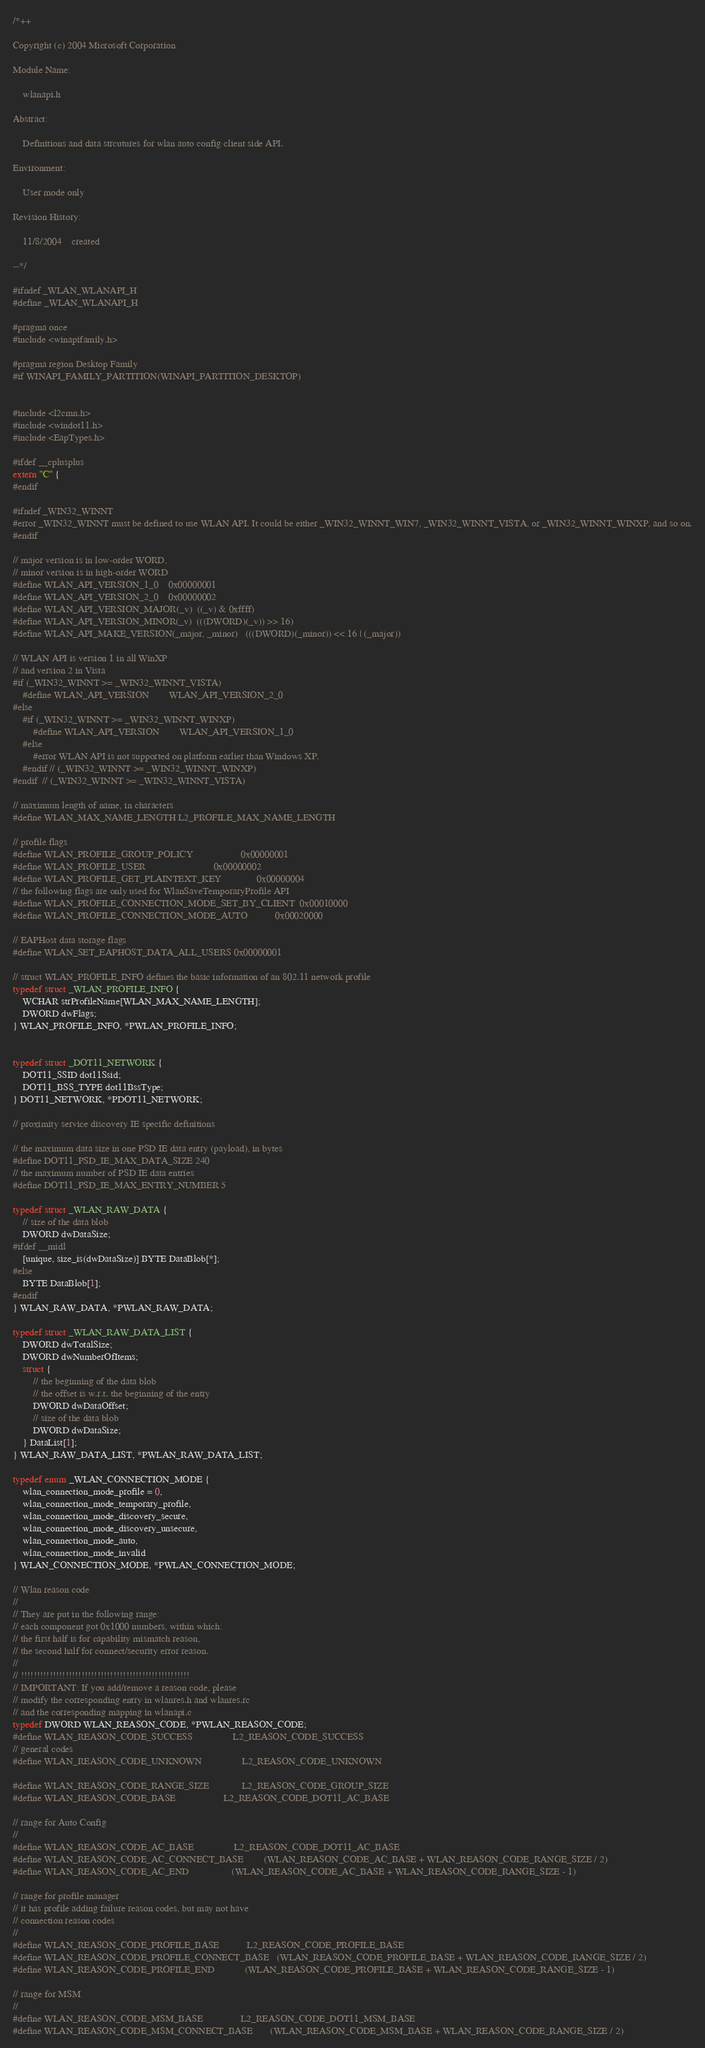<code> <loc_0><loc_0><loc_500><loc_500><_C_>/*++

Copyright (c) 2004 Microsoft Corporation

Module Name:

    wlanapi.h

Abstract:

    Definitions and data strcutures for wlan auto config client side API.

Environment:

    User mode only

Revision History:

    11/8/2004    created

--*/

#ifndef _WLAN_WLANAPI_H
#define _WLAN_WLANAPI_H

#pragma once
#include <winapifamily.h>

#pragma region Desktop Family
#if WINAPI_FAMILY_PARTITION(WINAPI_PARTITION_DESKTOP)


#include <l2cmn.h>
#include <windot11.h>
#include <EapTypes.h>

#ifdef __cplusplus
extern "C" {
#endif

#ifndef _WIN32_WINNT
#error _WIN32_WINNT must be defined to use WLAN API. It could be either _WIN32_WINNT_WIN7, _WIN32_WINNT_VISTA, or _WIN32_WINNT_WINXP, and so on.
#endif

// major version is in low-order WORD,
// minor version is in high-order WORD
#define WLAN_API_VERSION_1_0    0x00000001
#define WLAN_API_VERSION_2_0    0x00000002
#define WLAN_API_VERSION_MAJOR(_v)  ((_v) & 0xffff)
#define WLAN_API_VERSION_MINOR(_v)  (((DWORD)(_v)) >> 16)
#define WLAN_API_MAKE_VERSION(_major, _minor)   (((DWORD)(_minor)) << 16 | (_major))

// WLAN API is version 1 in all WinXP
// and version 2 in Vista
#if (_WIN32_WINNT >= _WIN32_WINNT_VISTA)
    #define WLAN_API_VERSION        WLAN_API_VERSION_2_0
#else
    #if (_WIN32_WINNT >= _WIN32_WINNT_WINXP)
        #define WLAN_API_VERSION        WLAN_API_VERSION_1_0
    #else
        #error WLAN API is not supported on platform earlier than Windows XP.
    #endif // (_WIN32_WINNT >= _WIN32_WINNT_WINXP)
#endif  // (_WIN32_WINNT >= _WIN32_WINNT_VISTA)

// maximum length of name, in characters
#define WLAN_MAX_NAME_LENGTH L2_PROFILE_MAX_NAME_LENGTH

// profile flags
#define WLAN_PROFILE_GROUP_POLICY                   0x00000001
#define WLAN_PROFILE_USER                           0x00000002
#define WLAN_PROFILE_GET_PLAINTEXT_KEY              0x00000004
// the following flags are only used for WlanSaveTemporaryProfile API
#define WLAN_PROFILE_CONNECTION_MODE_SET_BY_CLIENT  0x00010000
#define WLAN_PROFILE_CONNECTION_MODE_AUTO           0x00020000

// EAPHost data storage flags
#define WLAN_SET_EAPHOST_DATA_ALL_USERS 0x00000001

// struct WLAN_PROFILE_INFO defines the basic information of an 802.11 network profile
typedef struct _WLAN_PROFILE_INFO {
    WCHAR strProfileName[WLAN_MAX_NAME_LENGTH];
    DWORD dwFlags;
} WLAN_PROFILE_INFO, *PWLAN_PROFILE_INFO;


typedef struct _DOT11_NETWORK {
    DOT11_SSID dot11Ssid;
    DOT11_BSS_TYPE dot11BssType;
} DOT11_NETWORK, *PDOT11_NETWORK;

// proximity service discovery IE specific definitions

// the maximum data size in one PSD IE data entry (payload), in bytes
#define DOT11_PSD_IE_MAX_DATA_SIZE 240
// the maximum number of PSD IE data entries
#define DOT11_PSD_IE_MAX_ENTRY_NUMBER 5

typedef struct _WLAN_RAW_DATA {
    // size of the data blob
    DWORD dwDataSize;
#ifdef __midl
    [unique, size_is(dwDataSize)] BYTE DataBlob[*];
#else
    BYTE DataBlob[1];
#endif
} WLAN_RAW_DATA, *PWLAN_RAW_DATA;

typedef struct _WLAN_RAW_DATA_LIST {
    DWORD dwTotalSize;
    DWORD dwNumberOfItems;
    struct {
        // the beginning of the data blob
        // the offset is w.r.t. the beginning of the entry
        DWORD dwDataOffset;
        // size of the data blob
        DWORD dwDataSize;
    } DataList[1];
} WLAN_RAW_DATA_LIST, *PWLAN_RAW_DATA_LIST;

typedef enum _WLAN_CONNECTION_MODE {
    wlan_connection_mode_profile = 0,
    wlan_connection_mode_temporary_profile,
    wlan_connection_mode_discovery_secure,
    wlan_connection_mode_discovery_unsecure,
    wlan_connection_mode_auto,
    wlan_connection_mode_invalid
} WLAN_CONNECTION_MODE, *PWLAN_CONNECTION_MODE;

// Wlan reason code
//
// They are put in the following range:
// each component got 0x1000 numbers, within which:
// the first half is for capability mismatch reason,
// the second half for connect/security error reason.
//
// !!!!!!!!!!!!!!!!!!!!!!!!!!!!!!!!!!!!!!!!!!!!!!!!!!!!!
// IMPORTANT: If you add/remove a reason code, please
// modify the corresponding entry in wlanres.h and wlanres.rc
// and the corresponding mapping in wlanapi.c
typedef DWORD WLAN_REASON_CODE, *PWLAN_REASON_CODE;
#define WLAN_REASON_CODE_SUCCESS                L2_REASON_CODE_SUCCESS
// general codes
#define WLAN_REASON_CODE_UNKNOWN                L2_REASON_CODE_UNKNOWN

#define WLAN_REASON_CODE_RANGE_SIZE             L2_REASON_CODE_GROUP_SIZE
#define WLAN_REASON_CODE_BASE                   L2_REASON_CODE_DOT11_AC_BASE

// range for Auto Config
//
#define WLAN_REASON_CODE_AC_BASE                L2_REASON_CODE_DOT11_AC_BASE
#define WLAN_REASON_CODE_AC_CONNECT_BASE        (WLAN_REASON_CODE_AC_BASE + WLAN_REASON_CODE_RANGE_SIZE / 2)
#define WLAN_REASON_CODE_AC_END                 (WLAN_REASON_CODE_AC_BASE + WLAN_REASON_CODE_RANGE_SIZE - 1)

// range for profile manager
// it has profile adding failure reason codes, but may not have
// connection reason codes
//
#define WLAN_REASON_CODE_PROFILE_BASE           L2_REASON_CODE_PROFILE_BASE
#define WLAN_REASON_CODE_PROFILE_CONNECT_BASE   (WLAN_REASON_CODE_PROFILE_BASE + WLAN_REASON_CODE_RANGE_SIZE / 2)
#define WLAN_REASON_CODE_PROFILE_END            (WLAN_REASON_CODE_PROFILE_BASE + WLAN_REASON_CODE_RANGE_SIZE - 1)

// range for MSM
//
#define WLAN_REASON_CODE_MSM_BASE               L2_REASON_CODE_DOT11_MSM_BASE
#define WLAN_REASON_CODE_MSM_CONNECT_BASE       (WLAN_REASON_CODE_MSM_BASE + WLAN_REASON_CODE_RANGE_SIZE / 2)</code> 